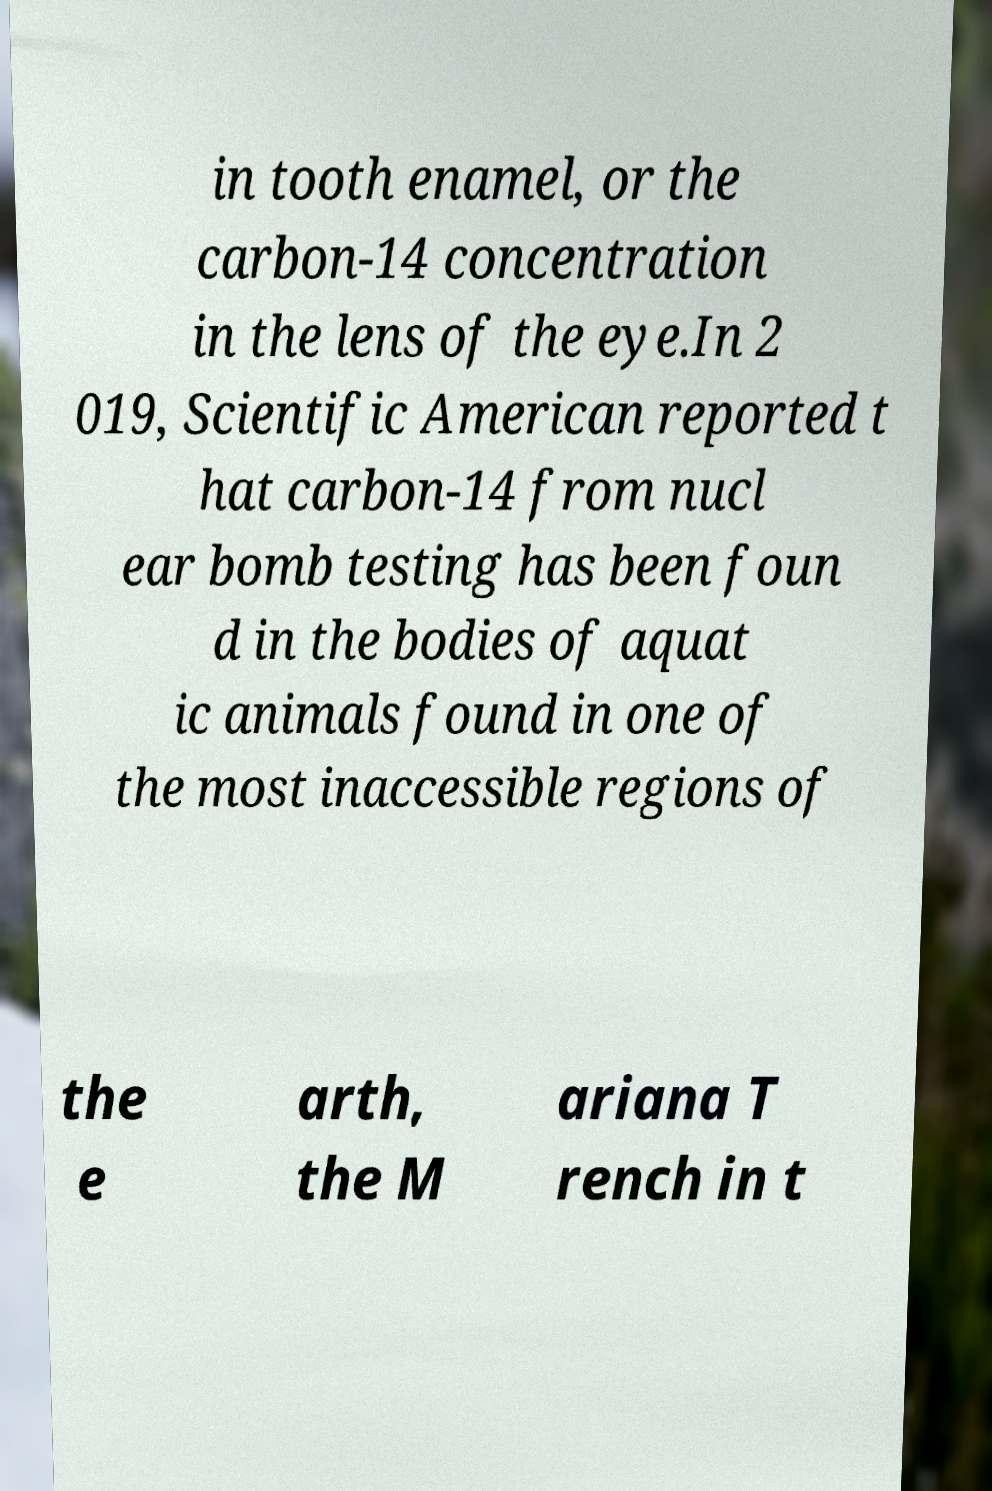Can you accurately transcribe the text from the provided image for me? in tooth enamel, or the carbon-14 concentration in the lens of the eye.In 2 019, Scientific American reported t hat carbon-14 from nucl ear bomb testing has been foun d in the bodies of aquat ic animals found in one of the most inaccessible regions of the e arth, the M ariana T rench in t 